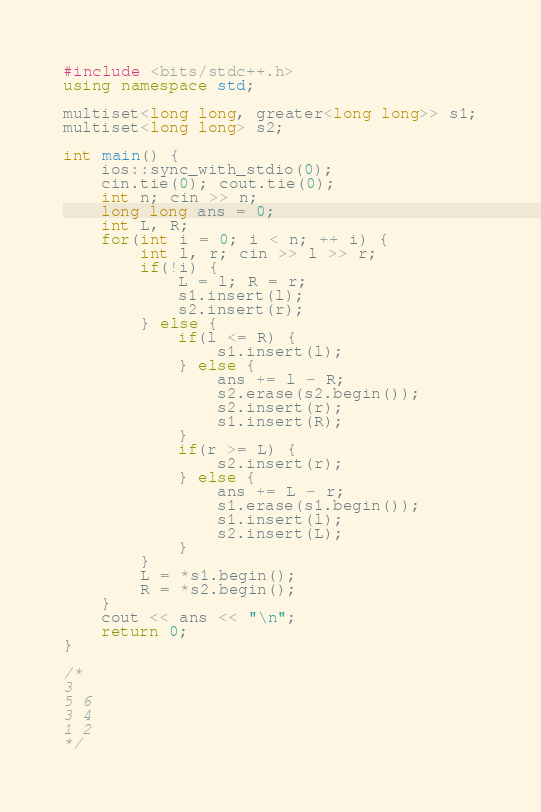<code> <loc_0><loc_0><loc_500><loc_500><_C++_>#include <bits/stdc++.h>
using namespace std;

multiset<long long, greater<long long>> s1;
multiset<long long> s2;

int main() {
	ios::sync_with_stdio(0);
	cin.tie(0); cout.tie(0);
	int n; cin >> n;
	long long ans = 0;
	int L, R;
	for(int i = 0; i < n; ++ i) {
		int l, r; cin >> l >> r;
		if(!i) {
			L = l; R = r;
			s1.insert(l);
			s2.insert(r);
		} else {
			if(l <= R) {
				s1.insert(l);	
			} else {
				ans += l - R;
				s2.erase(s2.begin());
				s2.insert(r);
				s1.insert(R);
			}
			if(r >= L) {
				s2.insert(r);
			} else {
				ans += L - r;
				s1.erase(s1.begin());
				s1.insert(l);
				s2.insert(L);
			}
		}
		L = *s1.begin();
		R = *s2.begin();
	}
	cout << ans << "\n";
	return 0;
}

/*
3
5 6
3 4
1 2
*/
</code> 